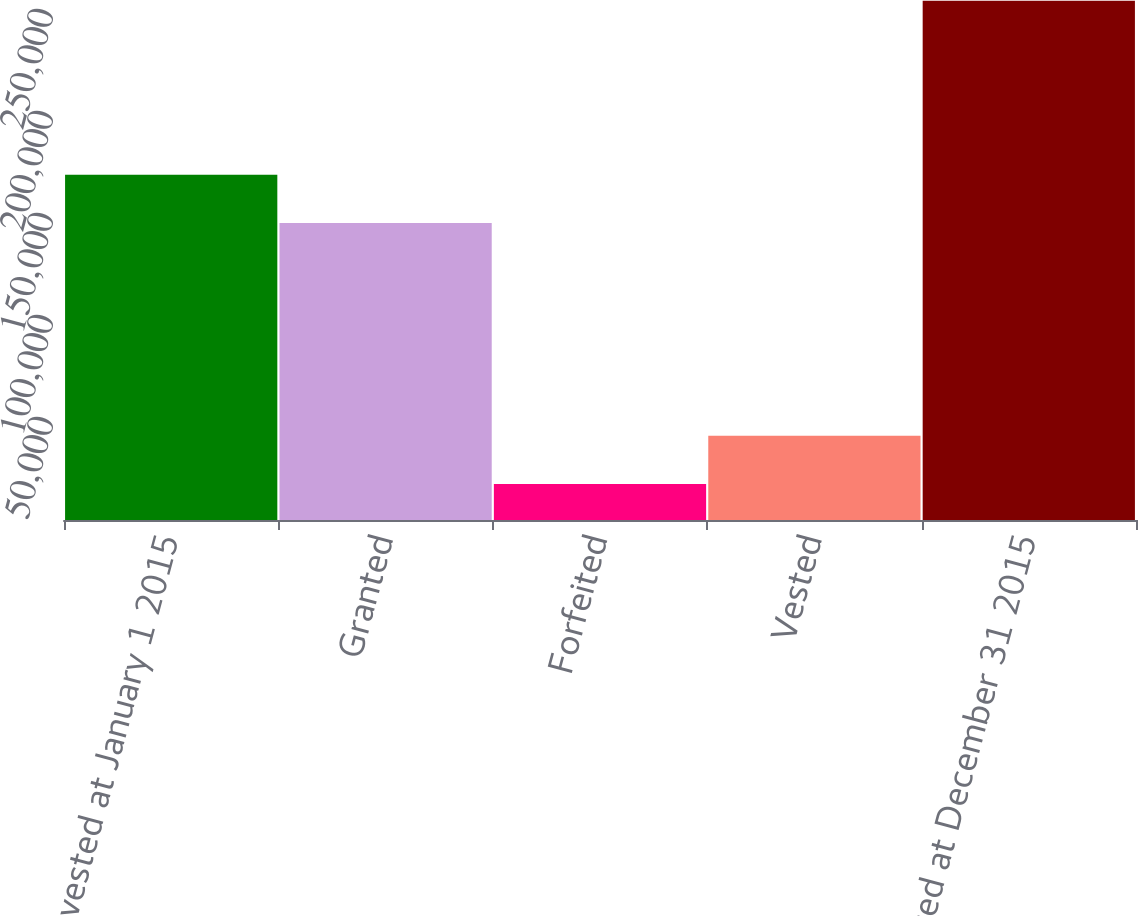Convert chart. <chart><loc_0><loc_0><loc_500><loc_500><bar_chart><fcel>Unvested at January 1 2015<fcel>Granted<fcel>Forfeited<fcel>Vested<fcel>Unvested at December 31 2015<nl><fcel>169242<fcel>145545<fcel>17597<fcel>41294.5<fcel>254572<nl></chart> 